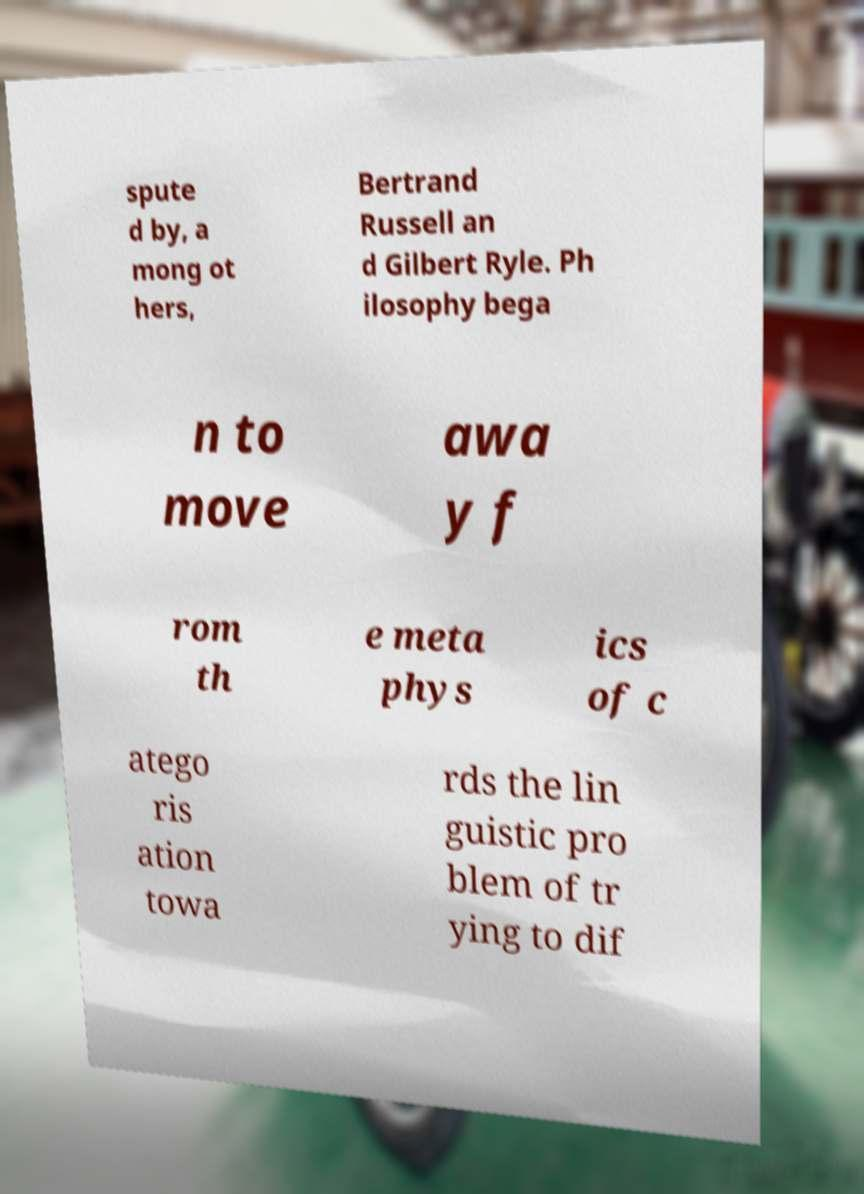Please identify and transcribe the text found in this image. spute d by, a mong ot hers, Bertrand Russell an d Gilbert Ryle. Ph ilosophy bega n to move awa y f rom th e meta phys ics of c atego ris ation towa rds the lin guistic pro blem of tr ying to dif 